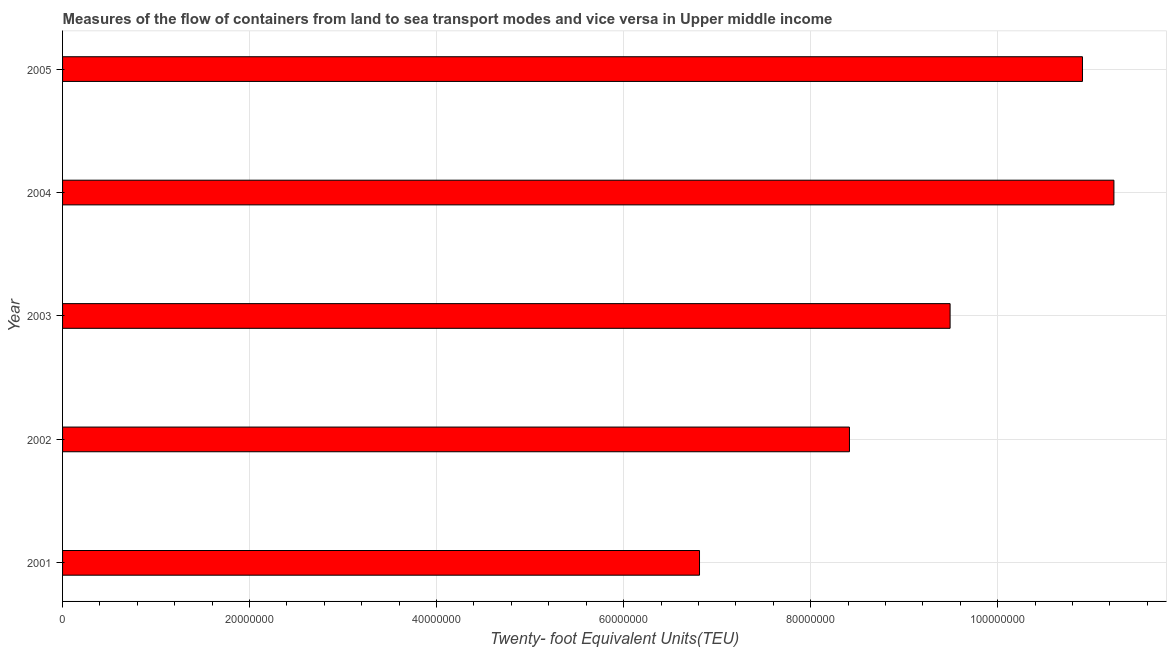Does the graph contain grids?
Make the answer very short. Yes. What is the title of the graph?
Provide a succinct answer. Measures of the flow of containers from land to sea transport modes and vice versa in Upper middle income. What is the label or title of the X-axis?
Make the answer very short. Twenty- foot Equivalent Units(TEU). What is the label or title of the Y-axis?
Ensure brevity in your answer.  Year. What is the container port traffic in 2005?
Keep it short and to the point. 1.09e+08. Across all years, what is the maximum container port traffic?
Give a very brief answer. 1.12e+08. Across all years, what is the minimum container port traffic?
Make the answer very short. 6.81e+07. In which year was the container port traffic minimum?
Keep it short and to the point. 2001. What is the sum of the container port traffic?
Provide a short and direct response. 4.69e+08. What is the difference between the container port traffic in 2001 and 2005?
Your answer should be compact. -4.10e+07. What is the average container port traffic per year?
Offer a very short reply. 9.37e+07. What is the median container port traffic?
Your answer should be compact. 9.49e+07. What is the ratio of the container port traffic in 2001 to that in 2004?
Offer a very short reply. 0.61. Is the difference between the container port traffic in 2003 and 2004 greater than the difference between any two years?
Ensure brevity in your answer.  No. What is the difference between the highest and the second highest container port traffic?
Offer a terse response. 3.36e+06. What is the difference between the highest and the lowest container port traffic?
Ensure brevity in your answer.  4.43e+07. How many bars are there?
Offer a terse response. 5. What is the Twenty- foot Equivalent Units(TEU) in 2001?
Your answer should be very brief. 6.81e+07. What is the Twenty- foot Equivalent Units(TEU) of 2002?
Provide a short and direct response. 8.42e+07. What is the Twenty- foot Equivalent Units(TEU) of 2003?
Keep it short and to the point. 9.49e+07. What is the Twenty- foot Equivalent Units(TEU) of 2004?
Provide a succinct answer. 1.12e+08. What is the Twenty- foot Equivalent Units(TEU) in 2005?
Your answer should be compact. 1.09e+08. What is the difference between the Twenty- foot Equivalent Units(TEU) in 2001 and 2002?
Provide a succinct answer. -1.60e+07. What is the difference between the Twenty- foot Equivalent Units(TEU) in 2001 and 2003?
Ensure brevity in your answer.  -2.68e+07. What is the difference between the Twenty- foot Equivalent Units(TEU) in 2001 and 2004?
Offer a terse response. -4.43e+07. What is the difference between the Twenty- foot Equivalent Units(TEU) in 2001 and 2005?
Your answer should be very brief. -4.10e+07. What is the difference between the Twenty- foot Equivalent Units(TEU) in 2002 and 2003?
Ensure brevity in your answer.  -1.08e+07. What is the difference between the Twenty- foot Equivalent Units(TEU) in 2002 and 2004?
Your answer should be very brief. -2.83e+07. What is the difference between the Twenty- foot Equivalent Units(TEU) in 2002 and 2005?
Make the answer very short. -2.49e+07. What is the difference between the Twenty- foot Equivalent Units(TEU) in 2003 and 2004?
Your answer should be compact. -1.75e+07. What is the difference between the Twenty- foot Equivalent Units(TEU) in 2003 and 2005?
Your answer should be very brief. -1.42e+07. What is the difference between the Twenty- foot Equivalent Units(TEU) in 2004 and 2005?
Make the answer very short. 3.36e+06. What is the ratio of the Twenty- foot Equivalent Units(TEU) in 2001 to that in 2002?
Offer a very short reply. 0.81. What is the ratio of the Twenty- foot Equivalent Units(TEU) in 2001 to that in 2003?
Ensure brevity in your answer.  0.72. What is the ratio of the Twenty- foot Equivalent Units(TEU) in 2001 to that in 2004?
Offer a terse response. 0.61. What is the ratio of the Twenty- foot Equivalent Units(TEU) in 2002 to that in 2003?
Your answer should be very brief. 0.89. What is the ratio of the Twenty- foot Equivalent Units(TEU) in 2002 to that in 2004?
Provide a short and direct response. 0.75. What is the ratio of the Twenty- foot Equivalent Units(TEU) in 2002 to that in 2005?
Make the answer very short. 0.77. What is the ratio of the Twenty- foot Equivalent Units(TEU) in 2003 to that in 2004?
Your answer should be compact. 0.84. What is the ratio of the Twenty- foot Equivalent Units(TEU) in 2003 to that in 2005?
Keep it short and to the point. 0.87. What is the ratio of the Twenty- foot Equivalent Units(TEU) in 2004 to that in 2005?
Your answer should be compact. 1.03. 